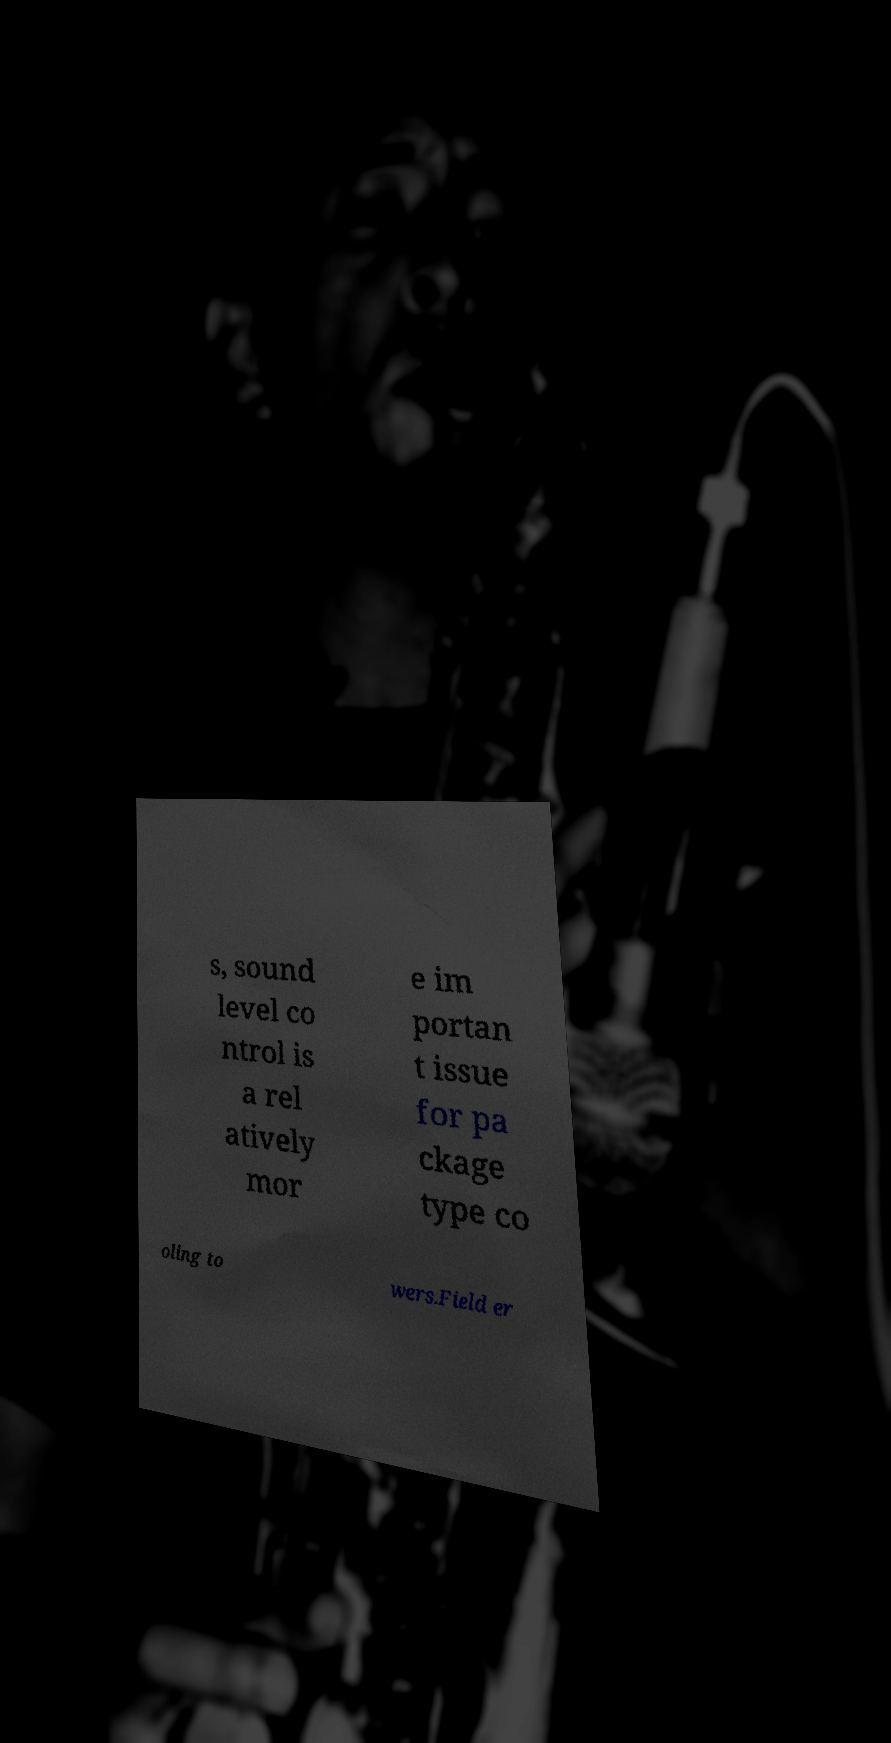Can you read and provide the text displayed in the image?This photo seems to have some interesting text. Can you extract and type it out for me? s, sound level co ntrol is a rel atively mor e im portan t issue for pa ckage type co oling to wers.Field er 